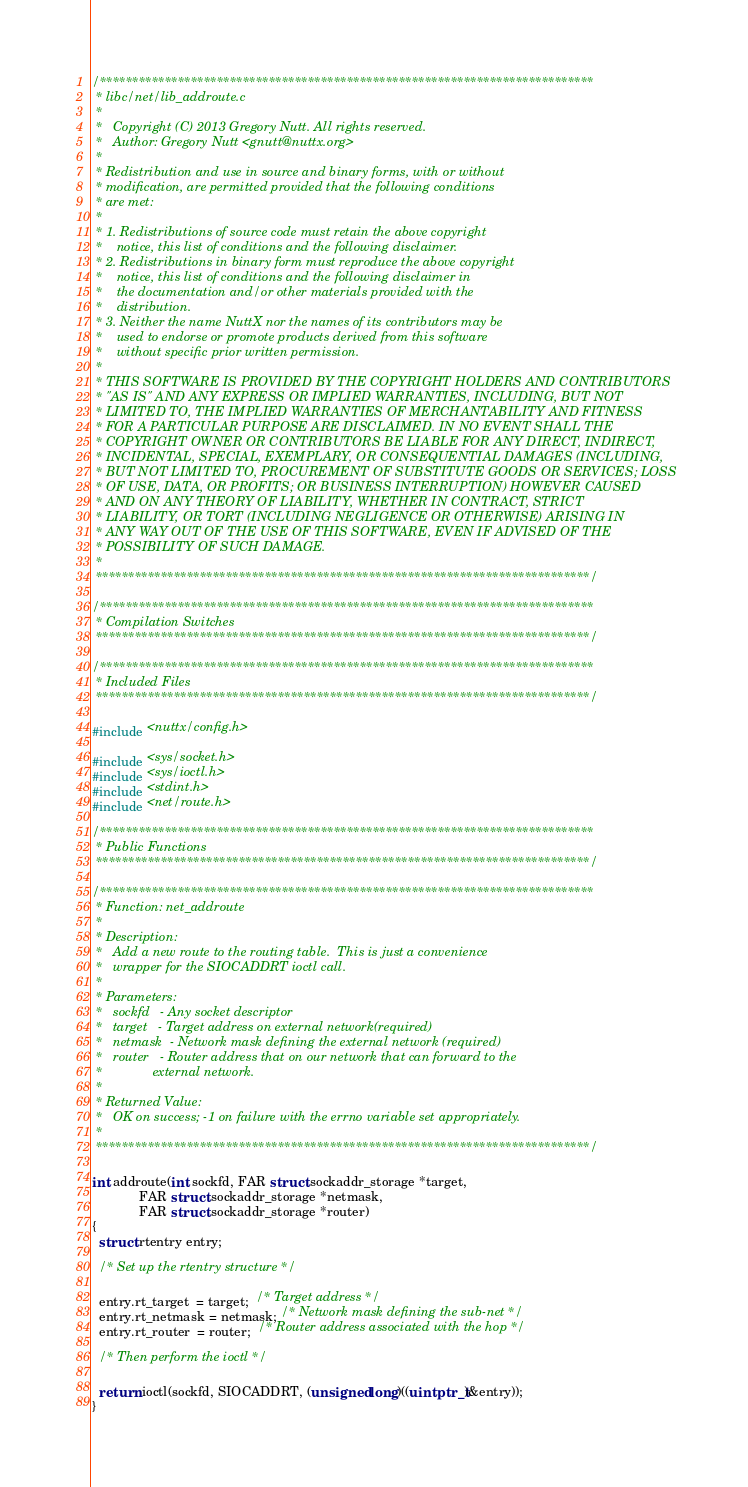<code> <loc_0><loc_0><loc_500><loc_500><_C_>/****************************************************************************
 * libc/net/lib_addroute.c
 *
 *   Copyright (C) 2013 Gregory Nutt. All rights reserved.
 *   Author: Gregory Nutt <gnutt@nuttx.org>
 *
 * Redistribution and use in source and binary forms, with or without
 * modification, are permitted provided that the following conditions
 * are met:
 *
 * 1. Redistributions of source code must retain the above copyright
 *    notice, this list of conditions and the following disclaimer.
 * 2. Redistributions in binary form must reproduce the above copyright
 *    notice, this list of conditions and the following disclaimer in
 *    the documentation and/or other materials provided with the
 *    distribution.
 * 3. Neither the name NuttX nor the names of its contributors may be
 *    used to endorse or promote products derived from this software
 *    without specific prior written permission.
 *
 * THIS SOFTWARE IS PROVIDED BY THE COPYRIGHT HOLDERS AND CONTRIBUTORS
 * "AS IS" AND ANY EXPRESS OR IMPLIED WARRANTIES, INCLUDING, BUT NOT
 * LIMITED TO, THE IMPLIED WARRANTIES OF MERCHANTABILITY AND FITNESS
 * FOR A PARTICULAR PURPOSE ARE DISCLAIMED. IN NO EVENT SHALL THE
 * COPYRIGHT OWNER OR CONTRIBUTORS BE LIABLE FOR ANY DIRECT, INDIRECT,
 * INCIDENTAL, SPECIAL, EXEMPLARY, OR CONSEQUENTIAL DAMAGES (INCLUDING,
 * BUT NOT LIMITED TO, PROCUREMENT OF SUBSTITUTE GOODS OR SERVICES; LOSS
 * OF USE, DATA, OR PROFITS; OR BUSINESS INTERRUPTION) HOWEVER CAUSED
 * AND ON ANY THEORY OF LIABILITY, WHETHER IN CONTRACT, STRICT
 * LIABILITY, OR TORT (INCLUDING NEGLIGENCE OR OTHERWISE) ARISING IN
 * ANY WAY OUT OF THE USE OF THIS SOFTWARE, EVEN IF ADVISED OF THE
 * POSSIBILITY OF SUCH DAMAGE.
 *
 ****************************************************************************/

/****************************************************************************
 * Compilation Switches
 ****************************************************************************/

/****************************************************************************
 * Included Files
 ****************************************************************************/

#include <nuttx/config.h>

#include <sys/socket.h>
#include <sys/ioctl.h>
#include <stdint.h>
#include <net/route.h>

/****************************************************************************
 * Public Functions
 ****************************************************************************/

/****************************************************************************
 * Function: net_addroute
 *
 * Description:
 *   Add a new route to the routing table.  This is just a convenience
 *   wrapper for the SIOCADDRT ioctl call.
 *
 * Parameters:
 *   sockfd   - Any socket descriptor
 *   target   - Target address on external network(required)
 *   netmask  - Network mask defining the external network (required)
 *   router   - Router address that on our network that can forward to the
 *              external network.
 *
 * Returned Value:
 *   OK on success; -1 on failure with the errno variable set appropriately.
 *
 ****************************************************************************/

int addroute(int sockfd, FAR struct sockaddr_storage *target,
             FAR struct sockaddr_storage *netmask,
             FAR struct sockaddr_storage *router)
{
  struct rtentry entry;

  /* Set up the rtentry structure */

  entry.rt_target  = target;  /* Target address */
  entry.rt_netmask = netmask; /* Network mask defining the sub-net */
  entry.rt_router  = router;  /* Router address associated with the hop */

  /* Then perform the ioctl */

  return ioctl(sockfd, SIOCADDRT, (unsigned long)((uintptr_t)&entry));
}
</code> 